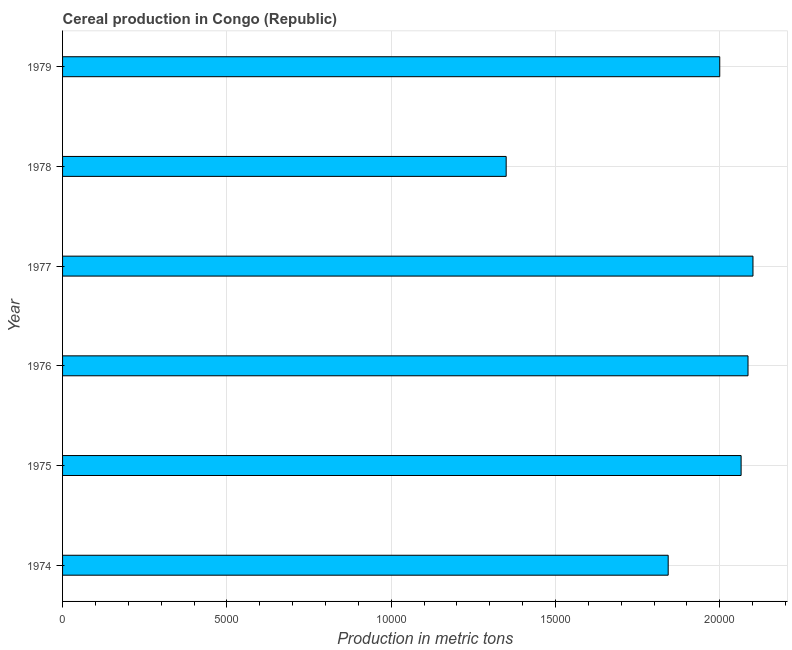Does the graph contain any zero values?
Your answer should be compact. No. Does the graph contain grids?
Keep it short and to the point. Yes. What is the title of the graph?
Give a very brief answer. Cereal production in Congo (Republic). What is the label or title of the X-axis?
Offer a very short reply. Production in metric tons. What is the cereal production in 1974?
Keep it short and to the point. 1.84e+04. Across all years, what is the maximum cereal production?
Provide a succinct answer. 2.10e+04. Across all years, what is the minimum cereal production?
Offer a very short reply. 1.35e+04. In which year was the cereal production minimum?
Your answer should be very brief. 1978. What is the sum of the cereal production?
Give a very brief answer. 1.14e+05. What is the difference between the cereal production in 1977 and 1979?
Offer a terse response. 1011. What is the average cereal production per year?
Offer a very short reply. 1.91e+04. What is the median cereal production?
Make the answer very short. 2.03e+04. In how many years, is the cereal production greater than 3000 metric tons?
Keep it short and to the point. 6. Do a majority of the years between 1976 and 1978 (inclusive) have cereal production greater than 9000 metric tons?
Your answer should be very brief. Yes. What is the ratio of the cereal production in 1976 to that in 1979?
Make the answer very short. 1.04. Is the difference between the cereal production in 1975 and 1979 greater than the difference between any two years?
Make the answer very short. No. What is the difference between the highest and the second highest cereal production?
Make the answer very short. 151. What is the difference between the highest and the lowest cereal production?
Provide a short and direct response. 7511. In how many years, is the cereal production greater than the average cereal production taken over all years?
Your answer should be compact. 4. Are all the bars in the graph horizontal?
Your response must be concise. Yes. How many years are there in the graph?
Offer a terse response. 6. What is the Production in metric tons of 1974?
Keep it short and to the point. 1.84e+04. What is the Production in metric tons in 1975?
Provide a succinct answer. 2.06e+04. What is the Production in metric tons in 1976?
Your answer should be compact. 2.09e+04. What is the Production in metric tons in 1977?
Give a very brief answer. 2.10e+04. What is the Production in metric tons in 1978?
Keep it short and to the point. 1.35e+04. What is the difference between the Production in metric tons in 1974 and 1975?
Your answer should be very brief. -2219. What is the difference between the Production in metric tons in 1974 and 1976?
Offer a terse response. -2429. What is the difference between the Production in metric tons in 1974 and 1977?
Your answer should be very brief. -2580. What is the difference between the Production in metric tons in 1974 and 1978?
Your answer should be very brief. 4931. What is the difference between the Production in metric tons in 1974 and 1979?
Offer a very short reply. -1569. What is the difference between the Production in metric tons in 1975 and 1976?
Give a very brief answer. -210. What is the difference between the Production in metric tons in 1975 and 1977?
Provide a succinct answer. -361. What is the difference between the Production in metric tons in 1975 and 1978?
Ensure brevity in your answer.  7150. What is the difference between the Production in metric tons in 1975 and 1979?
Give a very brief answer. 650. What is the difference between the Production in metric tons in 1976 and 1977?
Your answer should be compact. -151. What is the difference between the Production in metric tons in 1976 and 1978?
Ensure brevity in your answer.  7360. What is the difference between the Production in metric tons in 1976 and 1979?
Provide a short and direct response. 860. What is the difference between the Production in metric tons in 1977 and 1978?
Your answer should be compact. 7511. What is the difference between the Production in metric tons in 1977 and 1979?
Make the answer very short. 1011. What is the difference between the Production in metric tons in 1978 and 1979?
Ensure brevity in your answer.  -6500. What is the ratio of the Production in metric tons in 1974 to that in 1975?
Your answer should be compact. 0.89. What is the ratio of the Production in metric tons in 1974 to that in 1976?
Provide a succinct answer. 0.88. What is the ratio of the Production in metric tons in 1974 to that in 1977?
Your answer should be very brief. 0.88. What is the ratio of the Production in metric tons in 1974 to that in 1978?
Provide a succinct answer. 1.36. What is the ratio of the Production in metric tons in 1974 to that in 1979?
Your answer should be compact. 0.92. What is the ratio of the Production in metric tons in 1975 to that in 1976?
Offer a very short reply. 0.99. What is the ratio of the Production in metric tons in 1975 to that in 1978?
Offer a very short reply. 1.53. What is the ratio of the Production in metric tons in 1975 to that in 1979?
Give a very brief answer. 1.03. What is the ratio of the Production in metric tons in 1976 to that in 1978?
Provide a short and direct response. 1.54. What is the ratio of the Production in metric tons in 1976 to that in 1979?
Ensure brevity in your answer.  1.04. What is the ratio of the Production in metric tons in 1977 to that in 1978?
Offer a very short reply. 1.56. What is the ratio of the Production in metric tons in 1977 to that in 1979?
Offer a terse response. 1.05. What is the ratio of the Production in metric tons in 1978 to that in 1979?
Offer a very short reply. 0.68. 